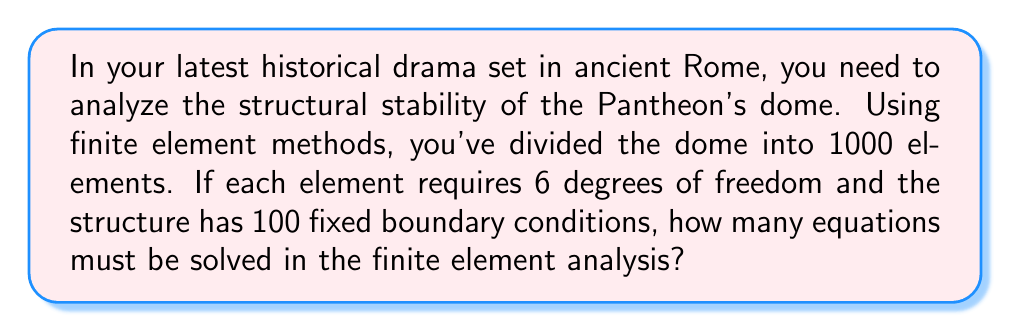Teach me how to tackle this problem. To solve this problem, we need to follow these steps:

1. Calculate the total degrees of freedom (DOF) for all elements:
   $$\text{Total DOF} = \text{Number of elements} \times \text{DOF per element}$$
   $$\text{Total DOF} = 1000 \times 6 = 6000$$

2. Account for the fixed boundary conditions:
   Each fixed boundary condition reduces the number of equations by 1.
   $$\text{Reduced DOF} = \text{Total DOF} - \text{Number of fixed boundary conditions}$$
   $$\text{Reduced DOF} = 6000 - 100 = 5900$$

3. The number of equations to be solved is equal to the reduced DOF:
   $$\text{Number of equations} = \text{Reduced DOF} = 5900$$

Therefore, 5900 equations must be solved in the finite element analysis of the Pantheon's dome.
Answer: 5900 equations 